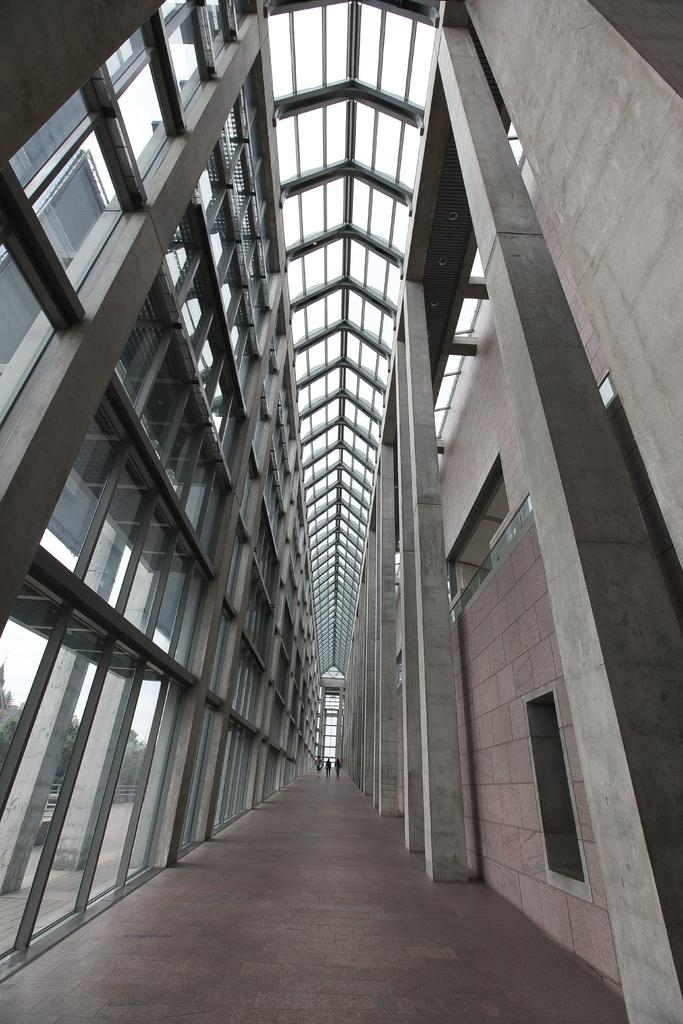What type of location is depicted in the image? The image is an inside view of a building. What material is present in the image? There is glass and a wall in the image. What architectural features can be seen in the image? There are pillars and a walkway in the image. Are there any people present in the image? Yes, there are people in the image. What can be seen through the grass on the left side of the image? Trees and the sky are visible through the grass on the left side of the image. What is the opinion of the lip in the image? There is no lip present in the image, so it is not possible to determine an opinion. 